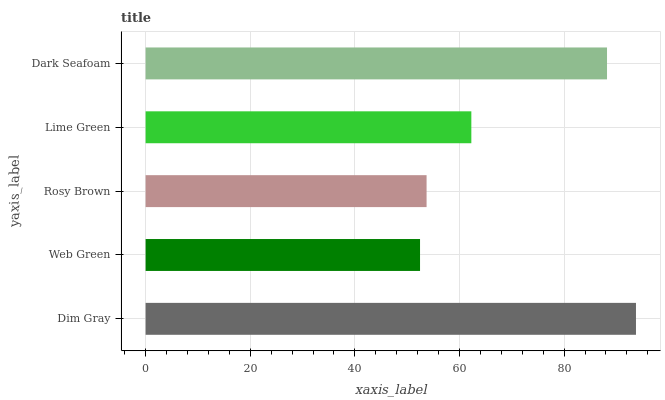Is Web Green the minimum?
Answer yes or no. Yes. Is Dim Gray the maximum?
Answer yes or no. Yes. Is Rosy Brown the minimum?
Answer yes or no. No. Is Rosy Brown the maximum?
Answer yes or no. No. Is Rosy Brown greater than Web Green?
Answer yes or no. Yes. Is Web Green less than Rosy Brown?
Answer yes or no. Yes. Is Web Green greater than Rosy Brown?
Answer yes or no. No. Is Rosy Brown less than Web Green?
Answer yes or no. No. Is Lime Green the high median?
Answer yes or no. Yes. Is Lime Green the low median?
Answer yes or no. Yes. Is Dim Gray the high median?
Answer yes or no. No. Is Dim Gray the low median?
Answer yes or no. No. 